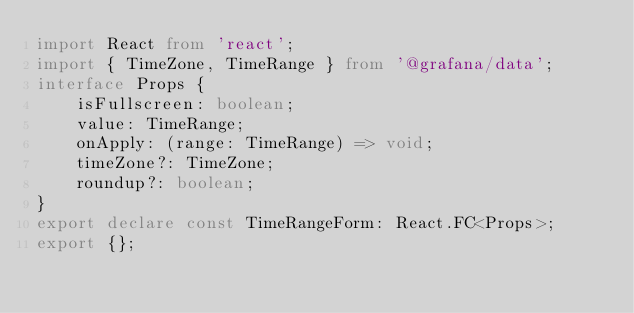<code> <loc_0><loc_0><loc_500><loc_500><_TypeScript_>import React from 'react';
import { TimeZone, TimeRange } from '@grafana/data';
interface Props {
    isFullscreen: boolean;
    value: TimeRange;
    onApply: (range: TimeRange) => void;
    timeZone?: TimeZone;
    roundup?: boolean;
}
export declare const TimeRangeForm: React.FC<Props>;
export {};
</code> 